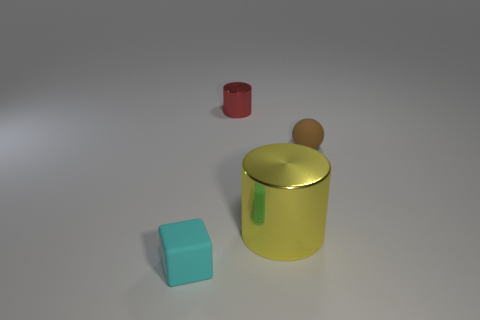How many objects are either brown spheres or tiny objects that are behind the tiny matte cube?
Your answer should be compact. 2. What number of other things are there of the same material as the brown sphere
Keep it short and to the point. 1. How many things are either small yellow rubber blocks or large shiny objects?
Provide a succinct answer. 1. Is the number of tiny rubber things that are on the left side of the ball greater than the number of small red cylinders on the left side of the small red metal cylinder?
Your answer should be very brief. Yes. There is a rubber object behind the small thing in front of the tiny thing to the right of the red cylinder; what is its size?
Provide a succinct answer. Small. There is another thing that is the same shape as the big yellow metal object; what is its color?
Provide a short and direct response. Red. Are there more small brown rubber spheres that are in front of the red metal thing than cyan matte cubes?
Offer a terse response. No. Does the tiny metallic object have the same shape as the metal object in front of the red cylinder?
Ensure brevity in your answer.  Yes. Are there any other things that have the same size as the yellow cylinder?
Offer a very short reply. No. What is the size of the other metal thing that is the same shape as the red object?
Provide a short and direct response. Large. 